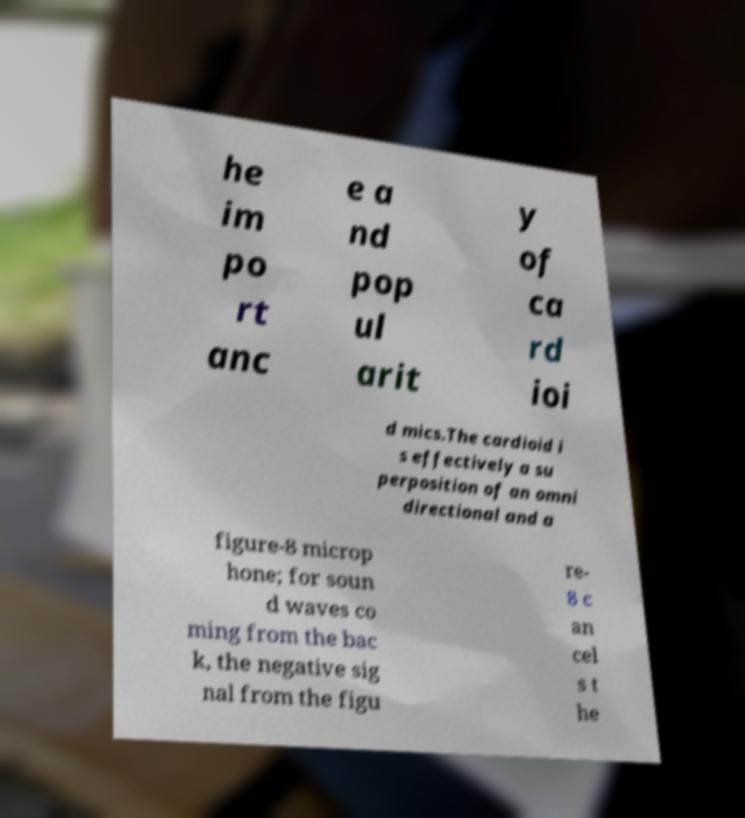There's text embedded in this image that I need extracted. Can you transcribe it verbatim? he im po rt anc e a nd pop ul arit y of ca rd ioi d mics.The cardioid i s effectively a su perposition of an omni directional and a figure-8 microp hone; for soun d waves co ming from the bac k, the negative sig nal from the figu re- 8 c an cel s t he 